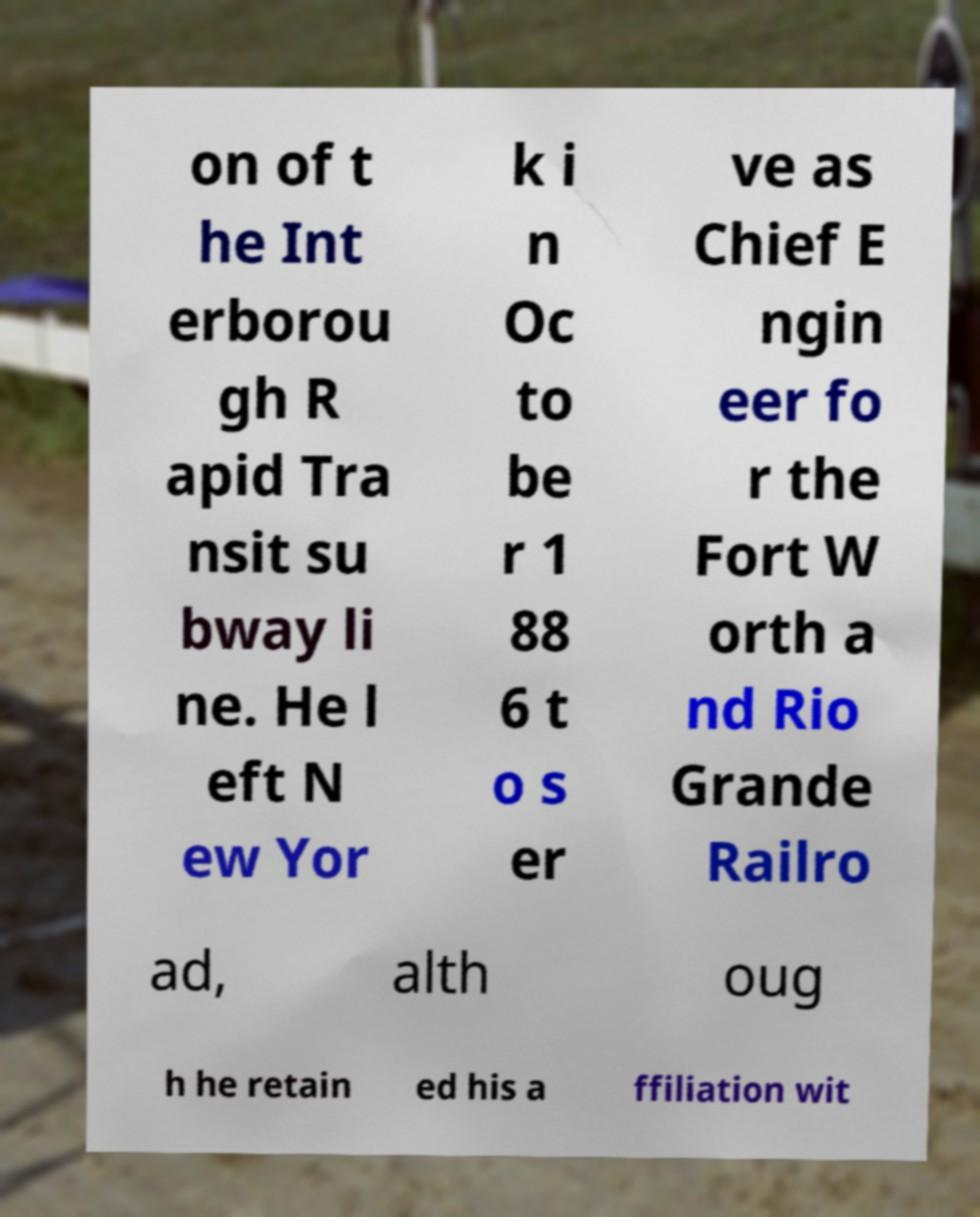Could you extract and type out the text from this image? on of t he Int erborou gh R apid Tra nsit su bway li ne. He l eft N ew Yor k i n Oc to be r 1 88 6 t o s er ve as Chief E ngin eer fo r the Fort W orth a nd Rio Grande Railro ad, alth oug h he retain ed his a ffiliation wit 